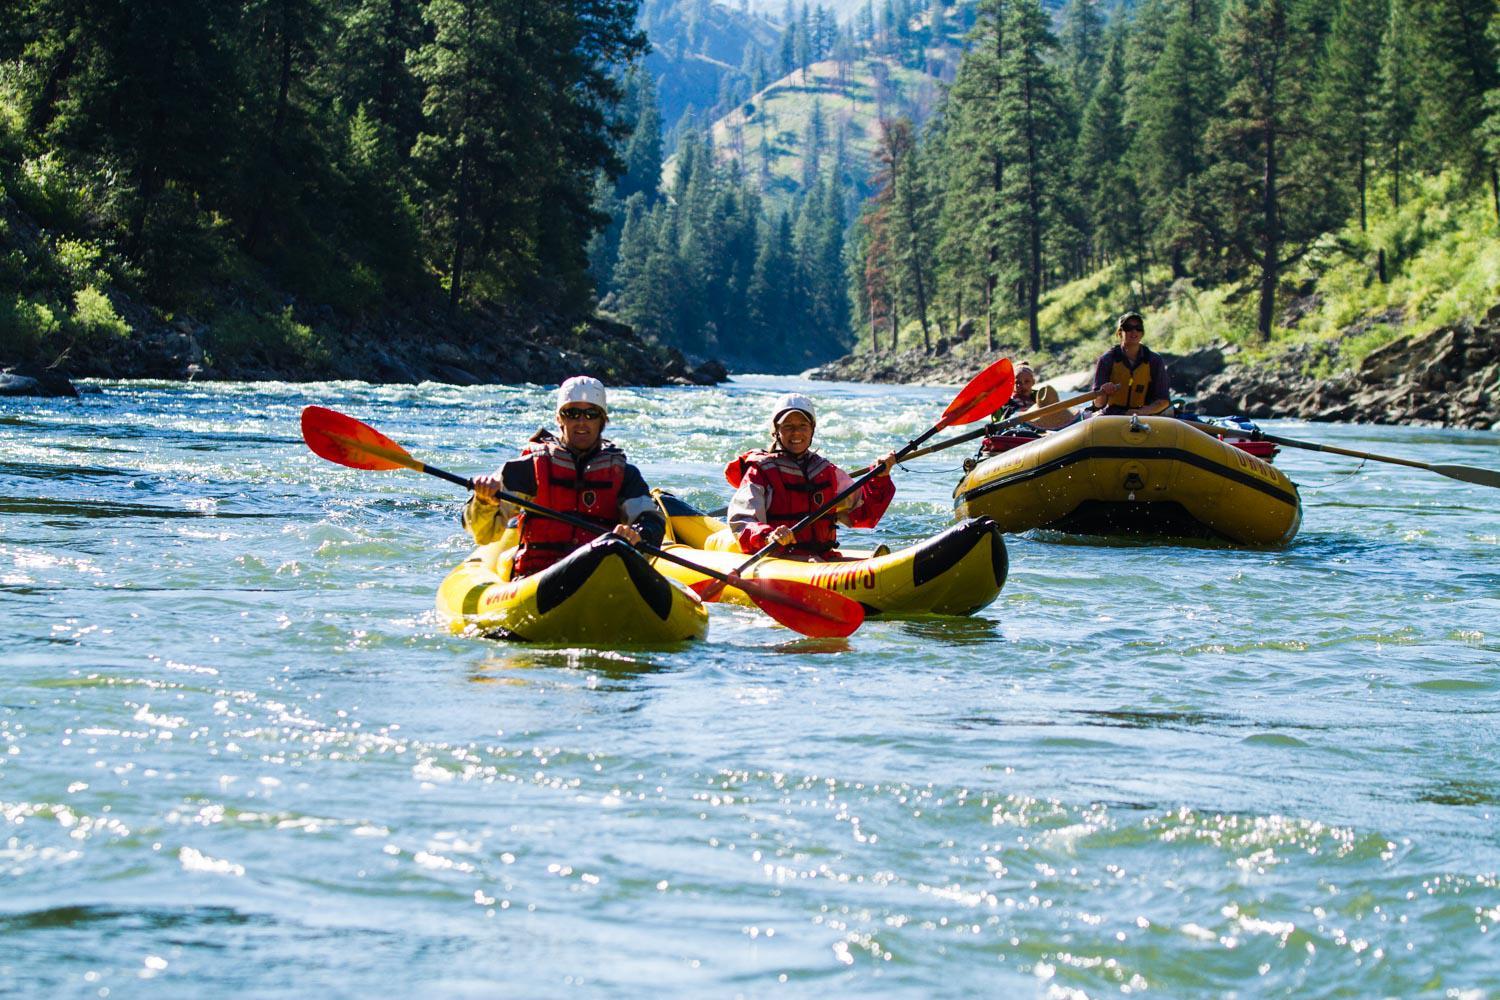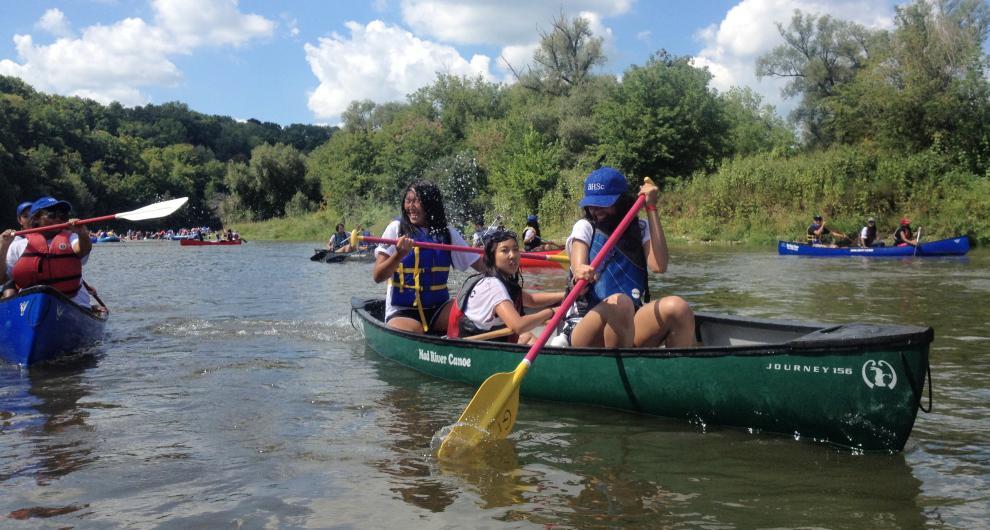The first image is the image on the left, the second image is the image on the right. Examine the images to the left and right. Is the description "All the boats are in the water." accurate? Answer yes or no. Yes. The first image is the image on the left, the second image is the image on the right. Examine the images to the left and right. Is the description "The left image includes a person standing by an empty canoe that is pulled up to the water's edge, with at least one other canoe on the water in the background." accurate? Answer yes or no. No. 